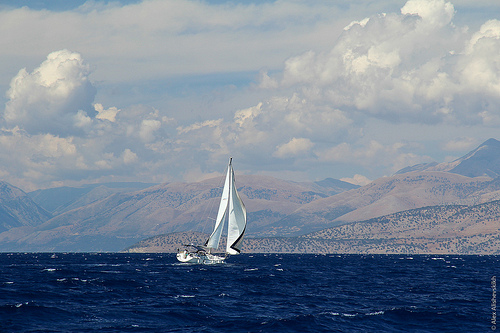Could you infer the possible location where this picture was taken? While it's not possible to determine the exact location without more context, the presence of the mountainous terrain in the backdrop and the vast open water suggests it could be a large inland sea or a coastal area along a substantial landmass. Places such as the Mediterranean, the coastlines along the Pacific Northwest, or regions near the Aegean Sea could offer similar geographical features. 